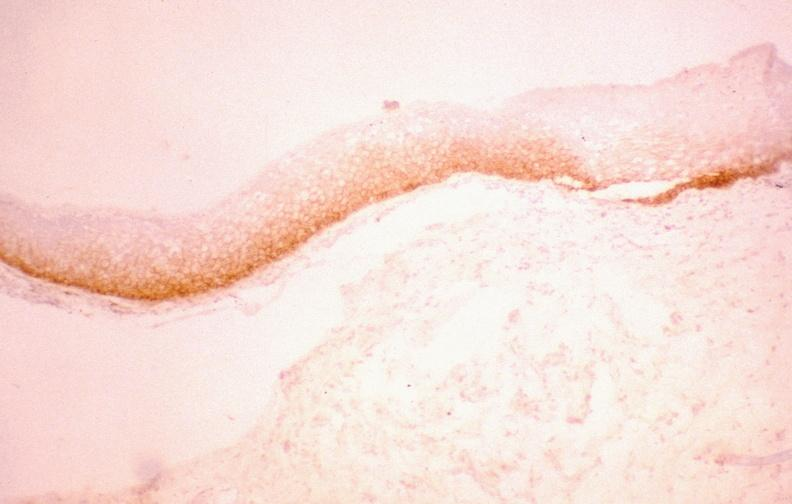s carcinoma metastatic lung present?
Answer the question using a single word or phrase. No 